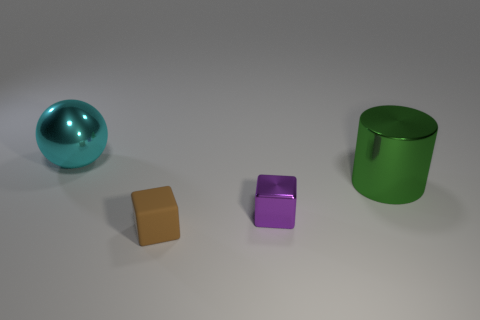Add 4 brown things. How many objects exist? 8 Subtract all spheres. How many objects are left? 3 Subtract all small brown matte cubes. Subtract all spheres. How many objects are left? 2 Add 2 metal balls. How many metal balls are left? 3 Add 2 tiny cyan matte objects. How many tiny cyan matte objects exist? 2 Subtract 0 purple cylinders. How many objects are left? 4 